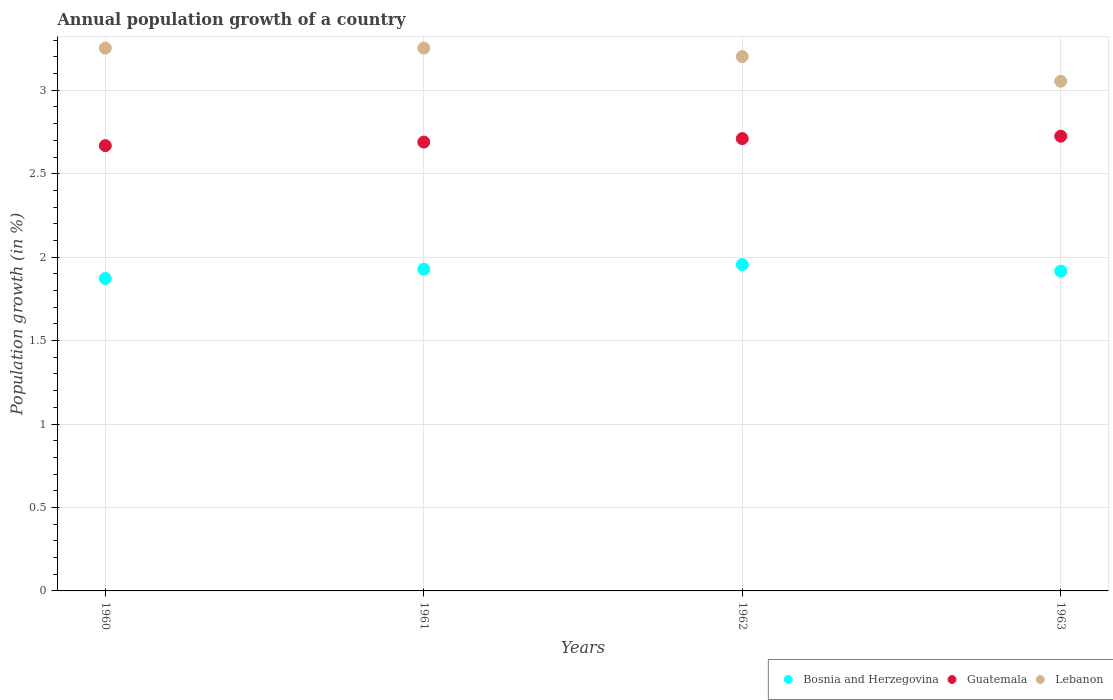What is the annual population growth in Lebanon in 1961?
Your response must be concise. 3.25. Across all years, what is the maximum annual population growth in Lebanon?
Provide a short and direct response. 3.25. Across all years, what is the minimum annual population growth in Lebanon?
Keep it short and to the point. 3.05. What is the total annual population growth in Lebanon in the graph?
Give a very brief answer. 12.76. What is the difference between the annual population growth in Bosnia and Herzegovina in 1961 and that in 1962?
Offer a very short reply. -0.03. What is the difference between the annual population growth in Bosnia and Herzegovina in 1960 and the annual population growth in Lebanon in 1963?
Provide a succinct answer. -1.18. What is the average annual population growth in Bosnia and Herzegovina per year?
Provide a succinct answer. 1.92. In the year 1961, what is the difference between the annual population growth in Bosnia and Herzegovina and annual population growth in Lebanon?
Your answer should be very brief. -1.32. In how many years, is the annual population growth in Bosnia and Herzegovina greater than 1.9 %?
Offer a terse response. 3. What is the ratio of the annual population growth in Guatemala in 1960 to that in 1961?
Provide a succinct answer. 0.99. What is the difference between the highest and the second highest annual population growth in Guatemala?
Offer a very short reply. 0.01. What is the difference between the highest and the lowest annual population growth in Lebanon?
Make the answer very short. 0.2. In how many years, is the annual population growth in Bosnia and Herzegovina greater than the average annual population growth in Bosnia and Herzegovina taken over all years?
Offer a terse response. 2. Is it the case that in every year, the sum of the annual population growth in Lebanon and annual population growth in Guatemala  is greater than the annual population growth in Bosnia and Herzegovina?
Give a very brief answer. Yes. Does the annual population growth in Lebanon monotonically increase over the years?
Offer a very short reply. No. Is the annual population growth in Guatemala strictly less than the annual population growth in Bosnia and Herzegovina over the years?
Provide a succinct answer. No. How many years are there in the graph?
Provide a succinct answer. 4. Are the values on the major ticks of Y-axis written in scientific E-notation?
Give a very brief answer. No. What is the title of the graph?
Provide a succinct answer. Annual population growth of a country. What is the label or title of the X-axis?
Give a very brief answer. Years. What is the label or title of the Y-axis?
Keep it short and to the point. Population growth (in %). What is the Population growth (in %) of Bosnia and Herzegovina in 1960?
Make the answer very short. 1.87. What is the Population growth (in %) of Guatemala in 1960?
Provide a short and direct response. 2.67. What is the Population growth (in %) in Lebanon in 1960?
Your answer should be compact. 3.25. What is the Population growth (in %) of Bosnia and Herzegovina in 1961?
Keep it short and to the point. 1.93. What is the Population growth (in %) in Guatemala in 1961?
Make the answer very short. 2.69. What is the Population growth (in %) in Lebanon in 1961?
Make the answer very short. 3.25. What is the Population growth (in %) of Bosnia and Herzegovina in 1962?
Provide a succinct answer. 1.96. What is the Population growth (in %) of Guatemala in 1962?
Keep it short and to the point. 2.71. What is the Population growth (in %) of Lebanon in 1962?
Ensure brevity in your answer.  3.2. What is the Population growth (in %) of Bosnia and Herzegovina in 1963?
Your answer should be compact. 1.92. What is the Population growth (in %) of Guatemala in 1963?
Give a very brief answer. 2.72. What is the Population growth (in %) in Lebanon in 1963?
Make the answer very short. 3.05. Across all years, what is the maximum Population growth (in %) of Bosnia and Herzegovina?
Your answer should be very brief. 1.96. Across all years, what is the maximum Population growth (in %) in Guatemala?
Make the answer very short. 2.72. Across all years, what is the maximum Population growth (in %) of Lebanon?
Make the answer very short. 3.25. Across all years, what is the minimum Population growth (in %) in Bosnia and Herzegovina?
Your answer should be very brief. 1.87. Across all years, what is the minimum Population growth (in %) of Guatemala?
Your response must be concise. 2.67. Across all years, what is the minimum Population growth (in %) of Lebanon?
Ensure brevity in your answer.  3.05. What is the total Population growth (in %) in Bosnia and Herzegovina in the graph?
Your answer should be very brief. 7.67. What is the total Population growth (in %) in Guatemala in the graph?
Keep it short and to the point. 10.79. What is the total Population growth (in %) in Lebanon in the graph?
Offer a terse response. 12.76. What is the difference between the Population growth (in %) in Bosnia and Herzegovina in 1960 and that in 1961?
Keep it short and to the point. -0.06. What is the difference between the Population growth (in %) in Guatemala in 1960 and that in 1961?
Offer a terse response. -0.02. What is the difference between the Population growth (in %) of Lebanon in 1960 and that in 1961?
Offer a terse response. -0. What is the difference between the Population growth (in %) of Bosnia and Herzegovina in 1960 and that in 1962?
Keep it short and to the point. -0.08. What is the difference between the Population growth (in %) in Guatemala in 1960 and that in 1962?
Your answer should be compact. -0.04. What is the difference between the Population growth (in %) of Lebanon in 1960 and that in 1962?
Ensure brevity in your answer.  0.05. What is the difference between the Population growth (in %) of Bosnia and Herzegovina in 1960 and that in 1963?
Offer a terse response. -0.04. What is the difference between the Population growth (in %) of Guatemala in 1960 and that in 1963?
Your answer should be very brief. -0.06. What is the difference between the Population growth (in %) of Lebanon in 1960 and that in 1963?
Your answer should be compact. 0.2. What is the difference between the Population growth (in %) of Bosnia and Herzegovina in 1961 and that in 1962?
Provide a short and direct response. -0.03. What is the difference between the Population growth (in %) in Guatemala in 1961 and that in 1962?
Your answer should be compact. -0.02. What is the difference between the Population growth (in %) in Lebanon in 1961 and that in 1962?
Keep it short and to the point. 0.05. What is the difference between the Population growth (in %) of Bosnia and Herzegovina in 1961 and that in 1963?
Offer a very short reply. 0.01. What is the difference between the Population growth (in %) in Guatemala in 1961 and that in 1963?
Your response must be concise. -0.04. What is the difference between the Population growth (in %) of Lebanon in 1961 and that in 1963?
Your answer should be compact. 0.2. What is the difference between the Population growth (in %) of Bosnia and Herzegovina in 1962 and that in 1963?
Provide a short and direct response. 0.04. What is the difference between the Population growth (in %) in Guatemala in 1962 and that in 1963?
Provide a short and direct response. -0.01. What is the difference between the Population growth (in %) of Lebanon in 1962 and that in 1963?
Provide a short and direct response. 0.15. What is the difference between the Population growth (in %) in Bosnia and Herzegovina in 1960 and the Population growth (in %) in Guatemala in 1961?
Your response must be concise. -0.82. What is the difference between the Population growth (in %) in Bosnia and Herzegovina in 1960 and the Population growth (in %) in Lebanon in 1961?
Give a very brief answer. -1.38. What is the difference between the Population growth (in %) of Guatemala in 1960 and the Population growth (in %) of Lebanon in 1961?
Keep it short and to the point. -0.58. What is the difference between the Population growth (in %) in Bosnia and Herzegovina in 1960 and the Population growth (in %) in Guatemala in 1962?
Ensure brevity in your answer.  -0.84. What is the difference between the Population growth (in %) in Bosnia and Herzegovina in 1960 and the Population growth (in %) in Lebanon in 1962?
Offer a very short reply. -1.33. What is the difference between the Population growth (in %) of Guatemala in 1960 and the Population growth (in %) of Lebanon in 1962?
Keep it short and to the point. -0.53. What is the difference between the Population growth (in %) of Bosnia and Herzegovina in 1960 and the Population growth (in %) of Guatemala in 1963?
Provide a succinct answer. -0.85. What is the difference between the Population growth (in %) of Bosnia and Herzegovina in 1960 and the Population growth (in %) of Lebanon in 1963?
Ensure brevity in your answer.  -1.18. What is the difference between the Population growth (in %) of Guatemala in 1960 and the Population growth (in %) of Lebanon in 1963?
Your answer should be compact. -0.39. What is the difference between the Population growth (in %) of Bosnia and Herzegovina in 1961 and the Population growth (in %) of Guatemala in 1962?
Provide a succinct answer. -0.78. What is the difference between the Population growth (in %) of Bosnia and Herzegovina in 1961 and the Population growth (in %) of Lebanon in 1962?
Provide a succinct answer. -1.27. What is the difference between the Population growth (in %) in Guatemala in 1961 and the Population growth (in %) in Lebanon in 1962?
Give a very brief answer. -0.51. What is the difference between the Population growth (in %) of Bosnia and Herzegovina in 1961 and the Population growth (in %) of Guatemala in 1963?
Provide a succinct answer. -0.8. What is the difference between the Population growth (in %) of Bosnia and Herzegovina in 1961 and the Population growth (in %) of Lebanon in 1963?
Offer a very short reply. -1.13. What is the difference between the Population growth (in %) in Guatemala in 1961 and the Population growth (in %) in Lebanon in 1963?
Offer a very short reply. -0.36. What is the difference between the Population growth (in %) in Bosnia and Herzegovina in 1962 and the Population growth (in %) in Guatemala in 1963?
Your answer should be very brief. -0.77. What is the difference between the Population growth (in %) of Bosnia and Herzegovina in 1962 and the Population growth (in %) of Lebanon in 1963?
Offer a very short reply. -1.1. What is the difference between the Population growth (in %) in Guatemala in 1962 and the Population growth (in %) in Lebanon in 1963?
Ensure brevity in your answer.  -0.34. What is the average Population growth (in %) in Bosnia and Herzegovina per year?
Ensure brevity in your answer.  1.92. What is the average Population growth (in %) in Guatemala per year?
Ensure brevity in your answer.  2.7. What is the average Population growth (in %) of Lebanon per year?
Provide a short and direct response. 3.19. In the year 1960, what is the difference between the Population growth (in %) of Bosnia and Herzegovina and Population growth (in %) of Guatemala?
Give a very brief answer. -0.8. In the year 1960, what is the difference between the Population growth (in %) of Bosnia and Herzegovina and Population growth (in %) of Lebanon?
Give a very brief answer. -1.38. In the year 1960, what is the difference between the Population growth (in %) in Guatemala and Population growth (in %) in Lebanon?
Offer a very short reply. -0.58. In the year 1961, what is the difference between the Population growth (in %) in Bosnia and Herzegovina and Population growth (in %) in Guatemala?
Give a very brief answer. -0.76. In the year 1961, what is the difference between the Population growth (in %) in Bosnia and Herzegovina and Population growth (in %) in Lebanon?
Give a very brief answer. -1.32. In the year 1961, what is the difference between the Population growth (in %) of Guatemala and Population growth (in %) of Lebanon?
Provide a succinct answer. -0.56. In the year 1962, what is the difference between the Population growth (in %) of Bosnia and Herzegovina and Population growth (in %) of Guatemala?
Ensure brevity in your answer.  -0.75. In the year 1962, what is the difference between the Population growth (in %) of Bosnia and Herzegovina and Population growth (in %) of Lebanon?
Keep it short and to the point. -1.25. In the year 1962, what is the difference between the Population growth (in %) of Guatemala and Population growth (in %) of Lebanon?
Make the answer very short. -0.49. In the year 1963, what is the difference between the Population growth (in %) of Bosnia and Herzegovina and Population growth (in %) of Guatemala?
Your answer should be very brief. -0.81. In the year 1963, what is the difference between the Population growth (in %) of Bosnia and Herzegovina and Population growth (in %) of Lebanon?
Your answer should be very brief. -1.14. In the year 1963, what is the difference between the Population growth (in %) in Guatemala and Population growth (in %) in Lebanon?
Your answer should be compact. -0.33. What is the ratio of the Population growth (in %) of Bosnia and Herzegovina in 1960 to that in 1961?
Your answer should be compact. 0.97. What is the ratio of the Population growth (in %) of Lebanon in 1960 to that in 1961?
Your answer should be very brief. 1. What is the ratio of the Population growth (in %) of Bosnia and Herzegovina in 1960 to that in 1962?
Make the answer very short. 0.96. What is the ratio of the Population growth (in %) in Guatemala in 1960 to that in 1962?
Provide a succinct answer. 0.98. What is the ratio of the Population growth (in %) in Lebanon in 1960 to that in 1962?
Ensure brevity in your answer.  1.02. What is the ratio of the Population growth (in %) in Bosnia and Herzegovina in 1960 to that in 1963?
Your answer should be compact. 0.98. What is the ratio of the Population growth (in %) in Guatemala in 1960 to that in 1963?
Offer a terse response. 0.98. What is the ratio of the Population growth (in %) in Lebanon in 1960 to that in 1963?
Your answer should be compact. 1.06. What is the ratio of the Population growth (in %) of Bosnia and Herzegovina in 1961 to that in 1962?
Offer a very short reply. 0.99. What is the ratio of the Population growth (in %) in Lebanon in 1961 to that in 1962?
Your answer should be very brief. 1.02. What is the ratio of the Population growth (in %) of Guatemala in 1961 to that in 1963?
Make the answer very short. 0.99. What is the ratio of the Population growth (in %) of Lebanon in 1961 to that in 1963?
Your answer should be very brief. 1.07. What is the ratio of the Population growth (in %) of Bosnia and Herzegovina in 1962 to that in 1963?
Provide a succinct answer. 1.02. What is the ratio of the Population growth (in %) in Guatemala in 1962 to that in 1963?
Your response must be concise. 0.99. What is the ratio of the Population growth (in %) in Lebanon in 1962 to that in 1963?
Provide a succinct answer. 1.05. What is the difference between the highest and the second highest Population growth (in %) of Bosnia and Herzegovina?
Give a very brief answer. 0.03. What is the difference between the highest and the second highest Population growth (in %) of Guatemala?
Your response must be concise. 0.01. What is the difference between the highest and the lowest Population growth (in %) of Bosnia and Herzegovina?
Provide a succinct answer. 0.08. What is the difference between the highest and the lowest Population growth (in %) in Guatemala?
Your response must be concise. 0.06. What is the difference between the highest and the lowest Population growth (in %) of Lebanon?
Ensure brevity in your answer.  0.2. 